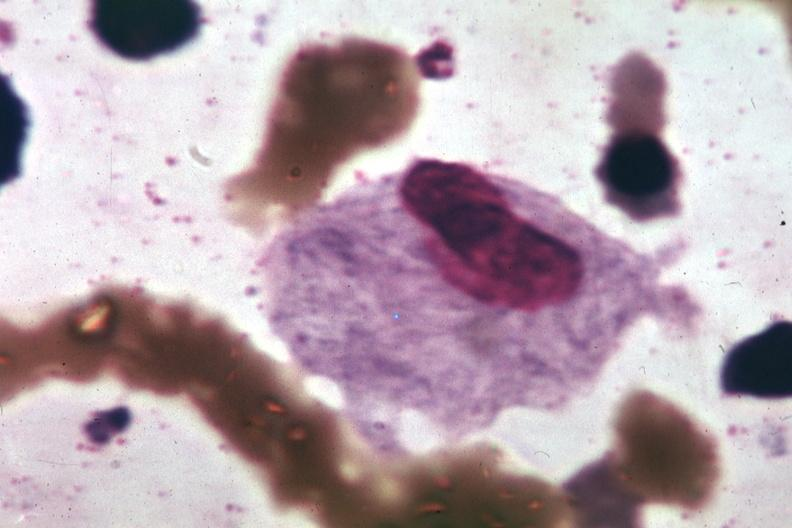what is present?
Answer the question using a single word or phrase. Gaucher cell 